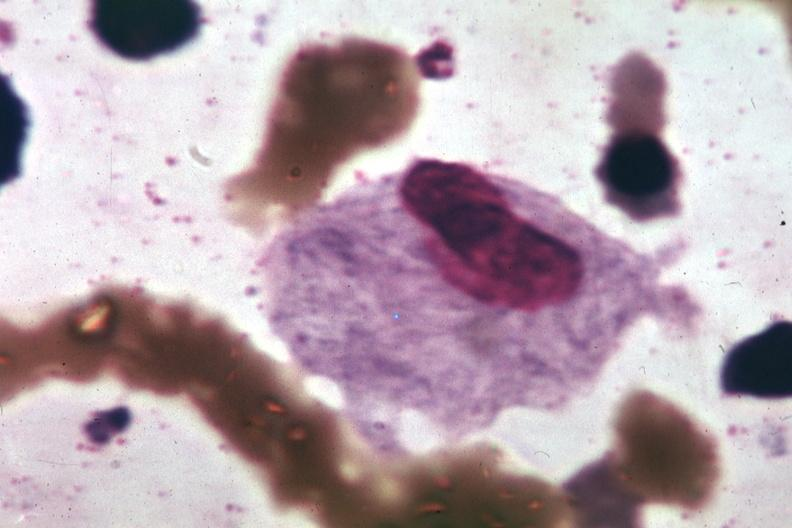what is present?
Answer the question using a single word or phrase. Gaucher cell 